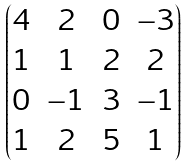Convert formula to latex. <formula><loc_0><loc_0><loc_500><loc_500>\begin{pmatrix} 4 & 2 & 0 & - 3 \\ 1 & 1 & 2 & 2 \\ 0 & - 1 & 3 & - 1 \\ 1 & 2 & 5 & 1 \end{pmatrix}</formula> 